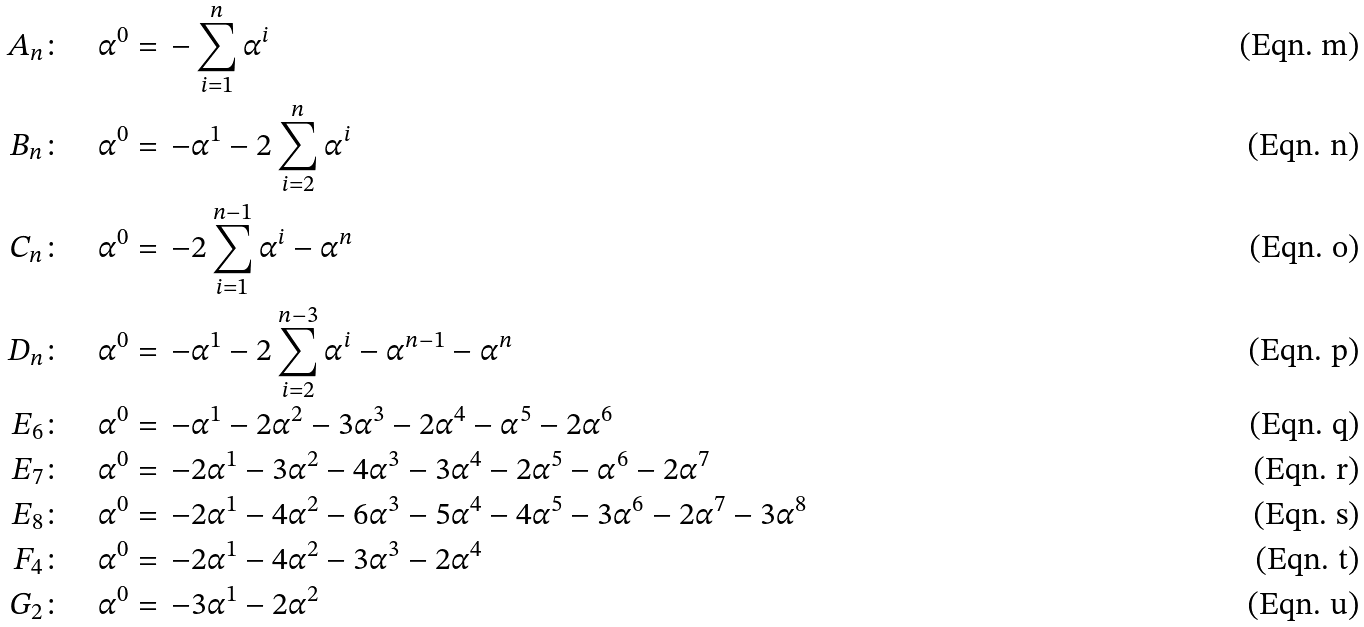Convert formula to latex. <formula><loc_0><loc_0><loc_500><loc_500>A _ { n } \colon \quad \alpha ^ { 0 } & = \, - \sum _ { i = 1 } ^ { n } \alpha ^ { i } \\ B _ { n } \colon \quad \alpha ^ { 0 } & = \, - \alpha ^ { 1 } - 2 \sum _ { i = 2 } ^ { n } \alpha ^ { i } \\ C _ { n } \colon \quad \alpha ^ { 0 } & = \, - 2 \sum _ { i = 1 } ^ { n - 1 } \alpha ^ { i } - \alpha ^ { n } \\ D _ { n } \colon \quad \alpha ^ { 0 } & = \, - \alpha ^ { 1 } - 2 \sum _ { i = 2 } ^ { n - 3 } \alpha ^ { i } - \alpha ^ { n - 1 } - \alpha ^ { n } \\ E _ { 6 } \colon \quad \alpha ^ { 0 } & = \, - \alpha ^ { 1 } - 2 \alpha ^ { 2 } - 3 \alpha ^ { 3 } - 2 \alpha ^ { 4 } - \alpha ^ { 5 } - 2 \alpha ^ { 6 } \\ E _ { 7 } \colon \quad \alpha ^ { 0 } & = \, - 2 \alpha ^ { 1 } - 3 \alpha ^ { 2 } - 4 \alpha ^ { 3 } - 3 \alpha ^ { 4 } - 2 \alpha ^ { 5 } - \alpha ^ { 6 } - 2 \alpha ^ { 7 } \\ E _ { 8 } \colon \quad \alpha ^ { 0 } & = \, - 2 \alpha ^ { 1 } - 4 \alpha ^ { 2 } - 6 \alpha ^ { 3 } - 5 \alpha ^ { 4 } - 4 \alpha ^ { 5 } - 3 \alpha ^ { 6 } - 2 \alpha ^ { 7 } - 3 \alpha ^ { 8 } \\ F _ { 4 } \colon \quad \alpha ^ { 0 } & = \, - 2 \alpha ^ { 1 } - 4 \alpha ^ { 2 } - 3 \alpha ^ { 3 } - 2 \alpha ^ { 4 } \\ G _ { 2 } \colon \quad \alpha ^ { 0 } & = \, - 3 \alpha ^ { 1 } - 2 \alpha ^ { 2 }</formula> 